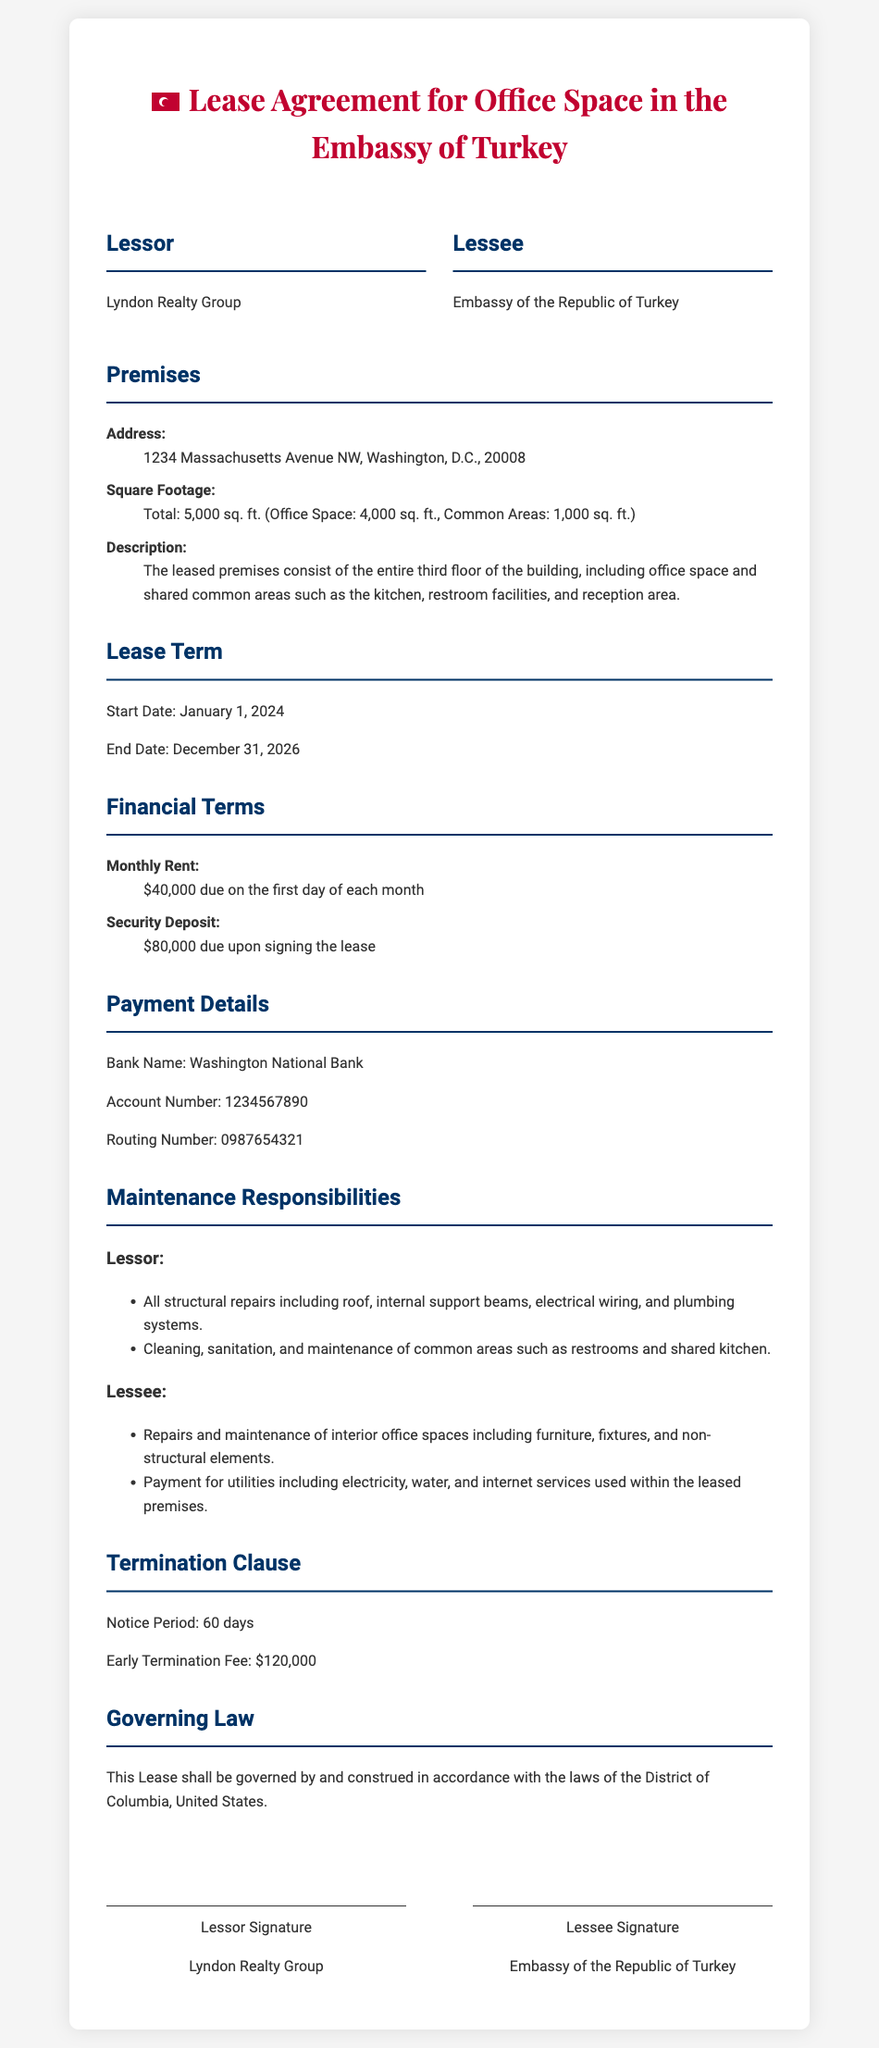What is the total square footage of the leased premises? The total square footage includes both office space and common areas, which is stated in the document as 5,000 sq. ft.
Answer: 5,000 sq. ft Who is the lessor? The name of the lessor is mentioned in the document as Lyndon Realty Group.
Answer: Lyndon Realty Group What is the monthly rent amount? The document specifies that the monthly rent is $40,000 due on the first day of each month.
Answer: $40,000 What is the security deposit required? The required security deposit upon signing the lease is stated as $80,000.
Answer: $80,000 What is the termination notice period? The document outlines that the notice period for termination is 60 days.
Answer: 60 days What are the maintenance responsibilities of the lessor? The document lists that the lessor is responsible for structural repairs and maintenance of common areas.
Answer: Structural repairs and common areas What is the early termination fee? The document specifies the early termination fee as $120,000.
Answer: $120,000 What is the address of the leased premises? The address of the leased premises is 1234 Massachusetts Avenue NW, Washington, D.C., 20008.
Answer: 1234 Massachusetts Avenue NW, Washington, D.C., 20008 What is the start date of the lease? The start date of the lease agreement is indicated as January 1, 2024.
Answer: January 1, 2024 What governing law applies to this lease? The lease specifies that it shall be governed by the laws of the District of Columbia, United States.
Answer: District of Columbia 